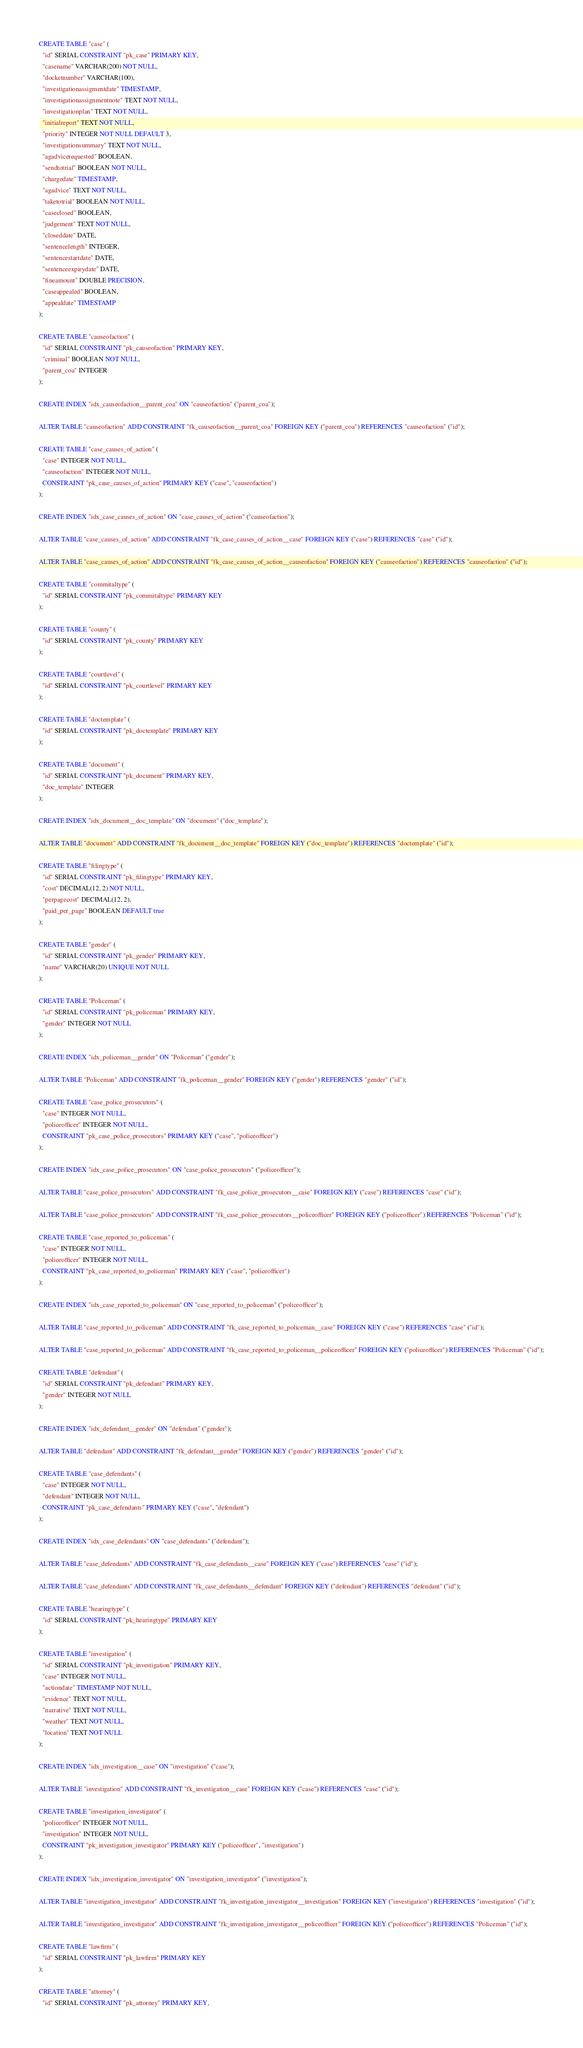Convert code to text. <code><loc_0><loc_0><loc_500><loc_500><_SQL_>CREATE TABLE "case" (
  "id" SERIAL CONSTRAINT "pk_case" PRIMARY KEY,
  "casename" VARCHAR(200) NOT NULL,
  "docketnumber" VARCHAR(100),
  "investigationassigmentdate" TIMESTAMP,
  "investigationassignmentnote" TEXT NOT NULL,
  "investigationplan" TEXT NOT NULL,
  "initialreport" TEXT NOT NULL,
  "priority" INTEGER NOT NULL DEFAULT 3,
  "investigationsummary" TEXT NOT NULL,
  "agadvicerequested" BOOLEAN,
  "sendtotrial" BOOLEAN NOT NULL,
  "chargedate" TIMESTAMP,
  "agadvice" TEXT NOT NULL,
  "taketotrial" BOOLEAN NOT NULL,
  "caseclosed" BOOLEAN,
  "judgement" TEXT NOT NULL,
  "closeddate" DATE,
  "sentencelength" INTEGER,
  "sentencestartdate" DATE,
  "sentenceexpirydate" DATE,
  "fineamount" DOUBLE PRECISION,
  "caseappealed" BOOLEAN,
  "appealdate" TIMESTAMP
);

CREATE TABLE "causeofaction" (
  "id" SERIAL CONSTRAINT "pk_causeofaction" PRIMARY KEY,
  "criminal" BOOLEAN NOT NULL,
  "parent_coa" INTEGER
);

CREATE INDEX "idx_causeofaction__parent_coa" ON "causeofaction" ("parent_coa");

ALTER TABLE "causeofaction" ADD CONSTRAINT "fk_causeofaction__parent_coa" FOREIGN KEY ("parent_coa") REFERENCES "causeofaction" ("id");

CREATE TABLE "case_causes_of_action" (
  "case" INTEGER NOT NULL,
  "causeofaction" INTEGER NOT NULL,
  CONSTRAINT "pk_case_causes_of_action" PRIMARY KEY ("case", "causeofaction")
);

CREATE INDEX "idx_case_causes_of_action" ON "case_causes_of_action" ("causeofaction");

ALTER TABLE "case_causes_of_action" ADD CONSTRAINT "fk_case_causes_of_action__case" FOREIGN KEY ("case") REFERENCES "case" ("id");

ALTER TABLE "case_causes_of_action" ADD CONSTRAINT "fk_case_causes_of_action__causeofaction" FOREIGN KEY ("causeofaction") REFERENCES "causeofaction" ("id");

CREATE TABLE "commitaltype" (
  "id" SERIAL CONSTRAINT "pk_commitaltype" PRIMARY KEY
);

CREATE TABLE "county" (
  "id" SERIAL CONSTRAINT "pk_county" PRIMARY KEY
);

CREATE TABLE "courtlevel" (
  "id" SERIAL CONSTRAINT "pk_courtlevel" PRIMARY KEY
);

CREATE TABLE "doctemplate" (
  "id" SERIAL CONSTRAINT "pk_doctemplate" PRIMARY KEY
);

CREATE TABLE "document" (
  "id" SERIAL CONSTRAINT "pk_document" PRIMARY KEY,
  "doc_template" INTEGER
);

CREATE INDEX "idx_document__doc_template" ON "document" ("doc_template");

ALTER TABLE "document" ADD CONSTRAINT "fk_document__doc_template" FOREIGN KEY ("doc_template") REFERENCES "doctemplate" ("id");

CREATE TABLE "filingtype" (
  "id" SERIAL CONSTRAINT "pk_filingtype" PRIMARY KEY,
  "cost" DECIMAL(12, 2) NOT NULL,
  "perpagecost" DECIMAL(12, 2),
  "paid_per_page" BOOLEAN DEFAULT true
);

CREATE TABLE "gender" (
  "id" SERIAL CONSTRAINT "pk_gender" PRIMARY KEY,
  "name" VARCHAR(20) UNIQUE NOT NULL
);

CREATE TABLE "Policeman" (
  "id" SERIAL CONSTRAINT "pk_policeman" PRIMARY KEY,
  "gender" INTEGER NOT NULL
);

CREATE INDEX "idx_policeman__gender" ON "Policeman" ("gender");

ALTER TABLE "Policeman" ADD CONSTRAINT "fk_policeman__gender" FOREIGN KEY ("gender") REFERENCES "gender" ("id");

CREATE TABLE "case_police_prosecutors" (
  "case" INTEGER NOT NULL,
  "policeofficer" INTEGER NOT NULL,
  CONSTRAINT "pk_case_police_prosecutors" PRIMARY KEY ("case", "policeofficer")
);

CREATE INDEX "idx_case_police_prosecutors" ON "case_police_prosecutors" ("policeofficer");

ALTER TABLE "case_police_prosecutors" ADD CONSTRAINT "fk_case_police_prosecutors__case" FOREIGN KEY ("case") REFERENCES "case" ("id");

ALTER TABLE "case_police_prosecutors" ADD CONSTRAINT "fk_case_police_prosecutors__policeofficer" FOREIGN KEY ("policeofficer") REFERENCES "Policeman" ("id");

CREATE TABLE "case_reported_to_policeman" (
  "case" INTEGER NOT NULL,
  "policeofficer" INTEGER NOT NULL,
  CONSTRAINT "pk_case_reported_to_policeman" PRIMARY KEY ("case", "policeofficer")
);

CREATE INDEX "idx_case_reported_to_policeman" ON "case_reported_to_policeman" ("policeofficer");

ALTER TABLE "case_reported_to_policeman" ADD CONSTRAINT "fk_case_reported_to_policeman__case" FOREIGN KEY ("case") REFERENCES "case" ("id");

ALTER TABLE "case_reported_to_policeman" ADD CONSTRAINT "fk_case_reported_to_policeman__policeofficer" FOREIGN KEY ("policeofficer") REFERENCES "Policeman" ("id");

CREATE TABLE "defendant" (
  "id" SERIAL CONSTRAINT "pk_defendant" PRIMARY KEY,
  "gender" INTEGER NOT NULL
);

CREATE INDEX "idx_defendant__gender" ON "defendant" ("gender");

ALTER TABLE "defendant" ADD CONSTRAINT "fk_defendant__gender" FOREIGN KEY ("gender") REFERENCES "gender" ("id");

CREATE TABLE "case_defendants" (
  "case" INTEGER NOT NULL,
  "defendant" INTEGER NOT NULL,
  CONSTRAINT "pk_case_defendants" PRIMARY KEY ("case", "defendant")
);

CREATE INDEX "idx_case_defendants" ON "case_defendants" ("defendant");

ALTER TABLE "case_defendants" ADD CONSTRAINT "fk_case_defendants__case" FOREIGN KEY ("case") REFERENCES "case" ("id");

ALTER TABLE "case_defendants" ADD CONSTRAINT "fk_case_defendants__defendant" FOREIGN KEY ("defendant") REFERENCES "defendant" ("id");

CREATE TABLE "hearingtype" (
  "id" SERIAL CONSTRAINT "pk_hearingtype" PRIMARY KEY
);

CREATE TABLE "investigation" (
  "id" SERIAL CONSTRAINT "pk_investigation" PRIMARY KEY,
  "case" INTEGER NOT NULL,
  "actiondate" TIMESTAMP NOT NULL,
  "evidence" TEXT NOT NULL,
  "narrative" TEXT NOT NULL,
  "weather" TEXT NOT NULL,
  "location" TEXT NOT NULL
);

CREATE INDEX "idx_investigation__case" ON "investigation" ("case");

ALTER TABLE "investigation" ADD CONSTRAINT "fk_investigation__case" FOREIGN KEY ("case") REFERENCES "case" ("id");

CREATE TABLE "investigation_investigator" (
  "policeofficer" INTEGER NOT NULL,
  "investigation" INTEGER NOT NULL,
  CONSTRAINT "pk_investigation_investigator" PRIMARY KEY ("policeofficer", "investigation")
);

CREATE INDEX "idx_investigation_investigator" ON "investigation_investigator" ("investigation");

ALTER TABLE "investigation_investigator" ADD CONSTRAINT "fk_investigation_investigator__investigation" FOREIGN KEY ("investigation") REFERENCES "investigation" ("id");

ALTER TABLE "investigation_investigator" ADD CONSTRAINT "fk_investigation_investigator__policeofficer" FOREIGN KEY ("policeofficer") REFERENCES "Policeman" ("id");

CREATE TABLE "lawfirm" (
  "id" SERIAL CONSTRAINT "pk_lawfirm" PRIMARY KEY
);

CREATE TABLE "attorney" (
  "id" SERIAL CONSTRAINT "pk_attorney" PRIMARY KEY,</code> 